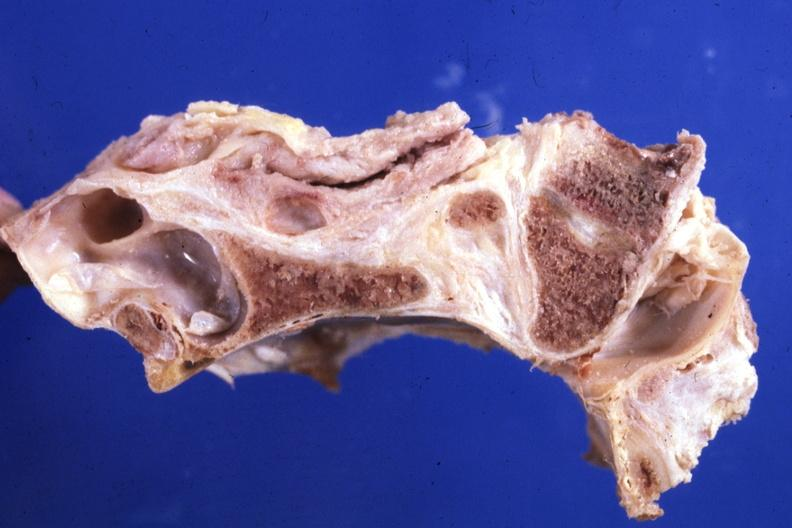what is present?
Answer the question using a single word or phrase. Rheumatoid arthritis 